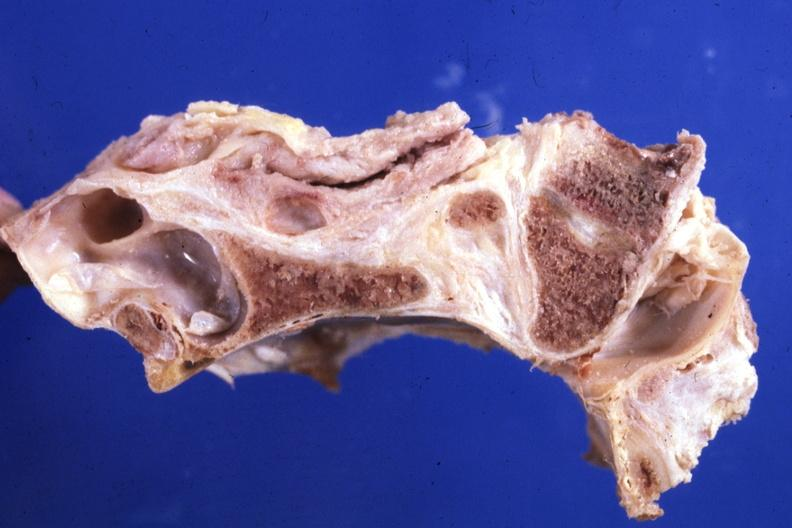what is present?
Answer the question using a single word or phrase. Rheumatoid arthritis 